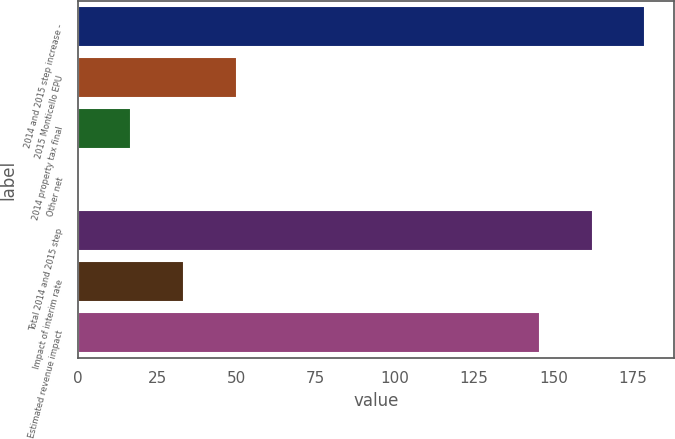Convert chart to OTSL. <chart><loc_0><loc_0><loc_500><loc_500><bar_chart><fcel>2014 and 2015 step increase -<fcel>2015 Monticello EPU<fcel>2014 property tax final<fcel>Other net<fcel>Total 2014 and 2015 step<fcel>Impact of interim rate<fcel>Estimated revenue impact<nl><fcel>178.98<fcel>49.97<fcel>16.79<fcel>0.2<fcel>162.39<fcel>33.38<fcel>145.8<nl></chart> 